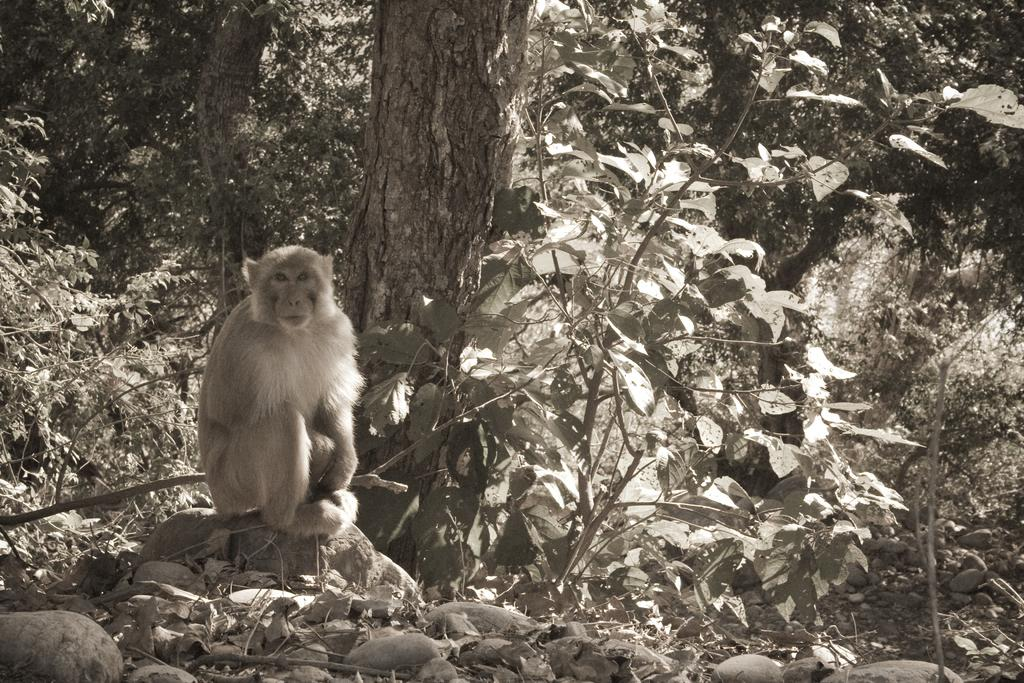What animal is the main subject of the image? There is a monkey in the image. What is the monkey sitting on? The monkey is sitting on a stone. What can be seen in the background of the image? There are trees in the background of the image. What type of government is depicted in the image? There is no depiction of a government in the image; it features a monkey sitting on a stone with trees in the background. 